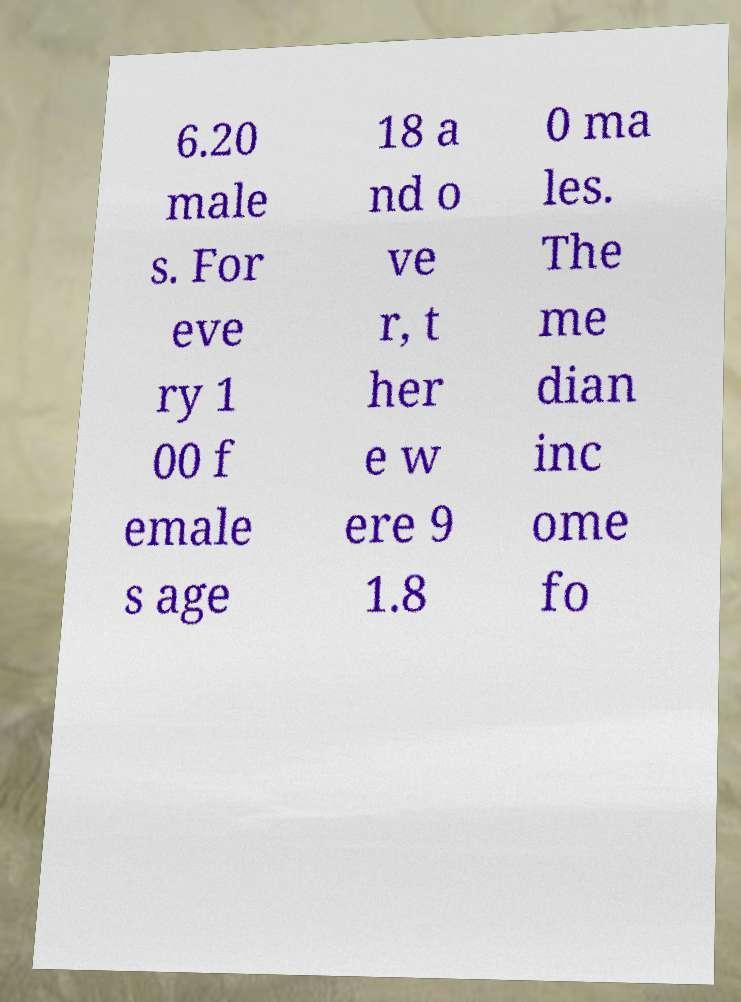I need the written content from this picture converted into text. Can you do that? 6.20 male s. For eve ry 1 00 f emale s age 18 a nd o ve r, t her e w ere 9 1.8 0 ma les. The me dian inc ome fo 